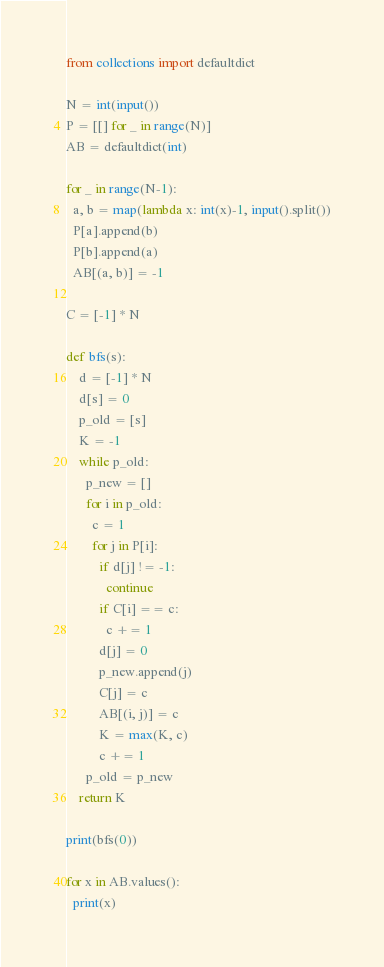<code> <loc_0><loc_0><loc_500><loc_500><_Python_>from collections import defaultdict

N = int(input())
P = [[] for _ in range(N)]
AB = defaultdict(int)

for _ in range(N-1):
  a, b = map(lambda x: int(x)-1, input().split())
  P[a].append(b)
  P[b].append(a)
  AB[(a, b)] = -1

C = [-1] * N

def bfs(s):
    d = [-1] * N
    d[s] = 0
    p_old = [s]
    K = -1
    while p_old:
      p_new = []
      for i in p_old:
        c = 1
        for j in P[i]:
          if d[j] != -1:
            continue
          if C[i] == c:
            c += 1
          d[j] = 0
          p_new.append(j)
          C[j] = c
          AB[(i, j)] = c
          K = max(K, c)
          c += 1
      p_old = p_new
    return K

print(bfs(0))

for x in AB.values():
  print(x)
</code> 